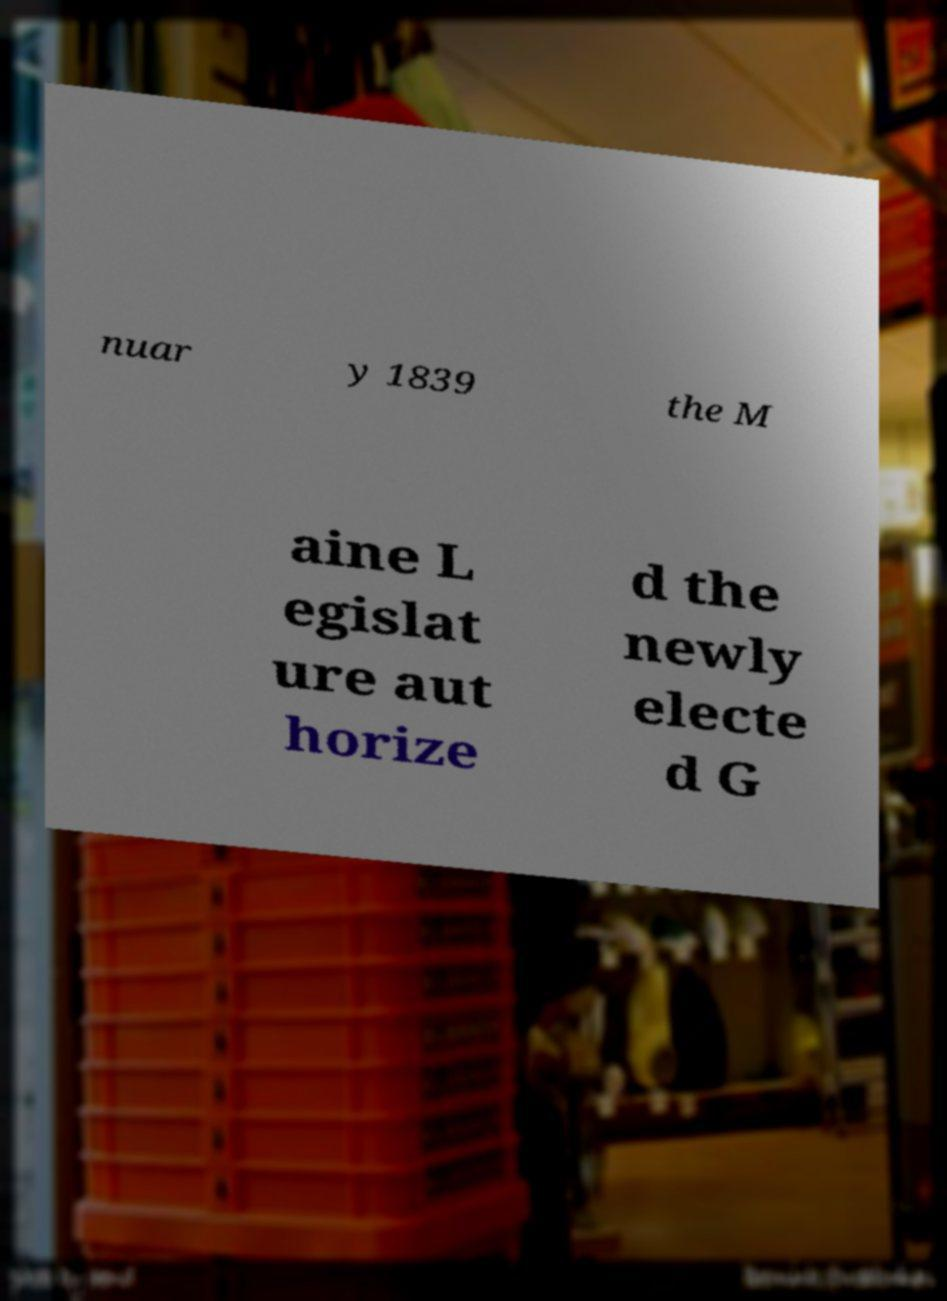I need the written content from this picture converted into text. Can you do that? nuar y 1839 the M aine L egislat ure aut horize d the newly electe d G 